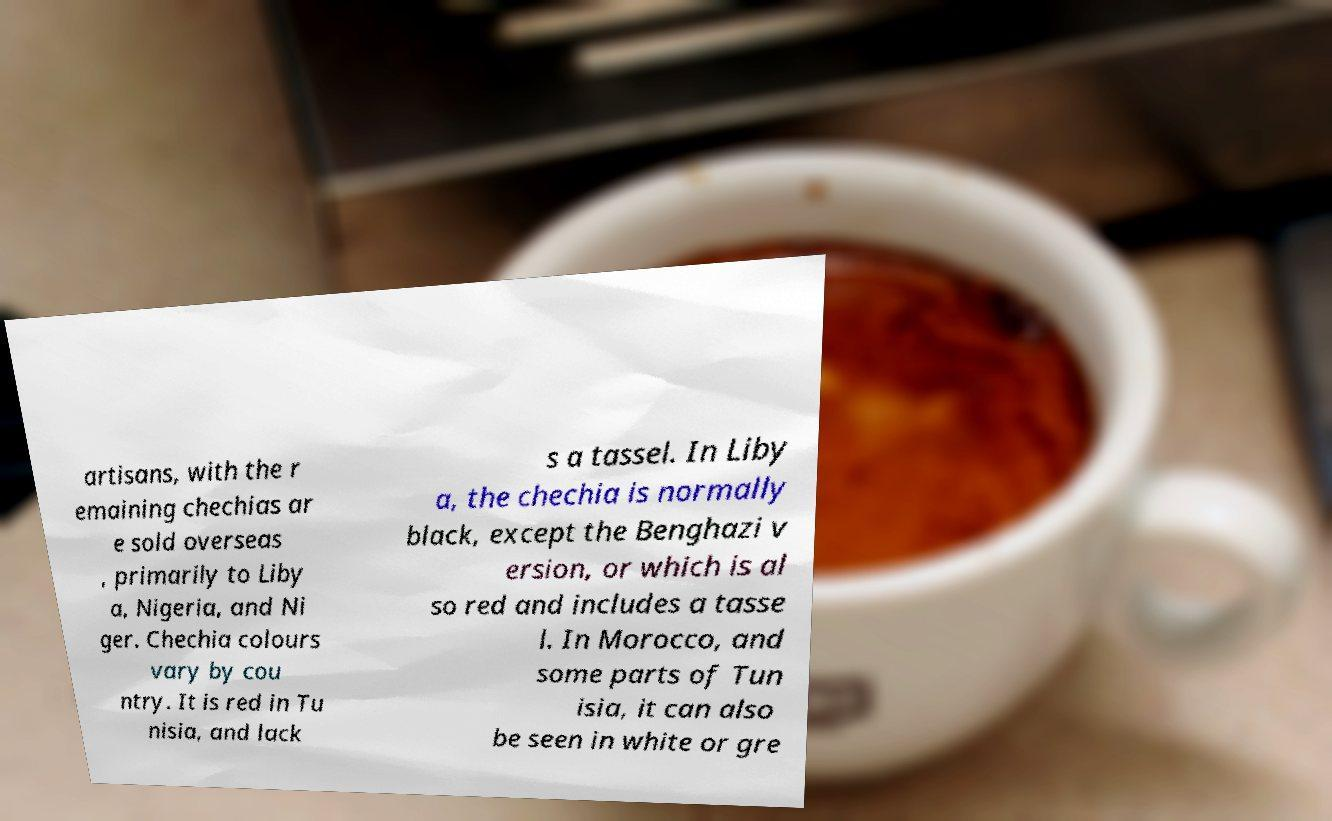I need the written content from this picture converted into text. Can you do that? artisans, with the r emaining chechias ar e sold overseas , primarily to Liby a, Nigeria, and Ni ger. Chechia colours vary by cou ntry. It is red in Tu nisia, and lack s a tassel. In Liby a, the chechia is normally black, except the Benghazi v ersion, or which is al so red and includes a tasse l. In Morocco, and some parts of Tun isia, it can also be seen in white or gre 